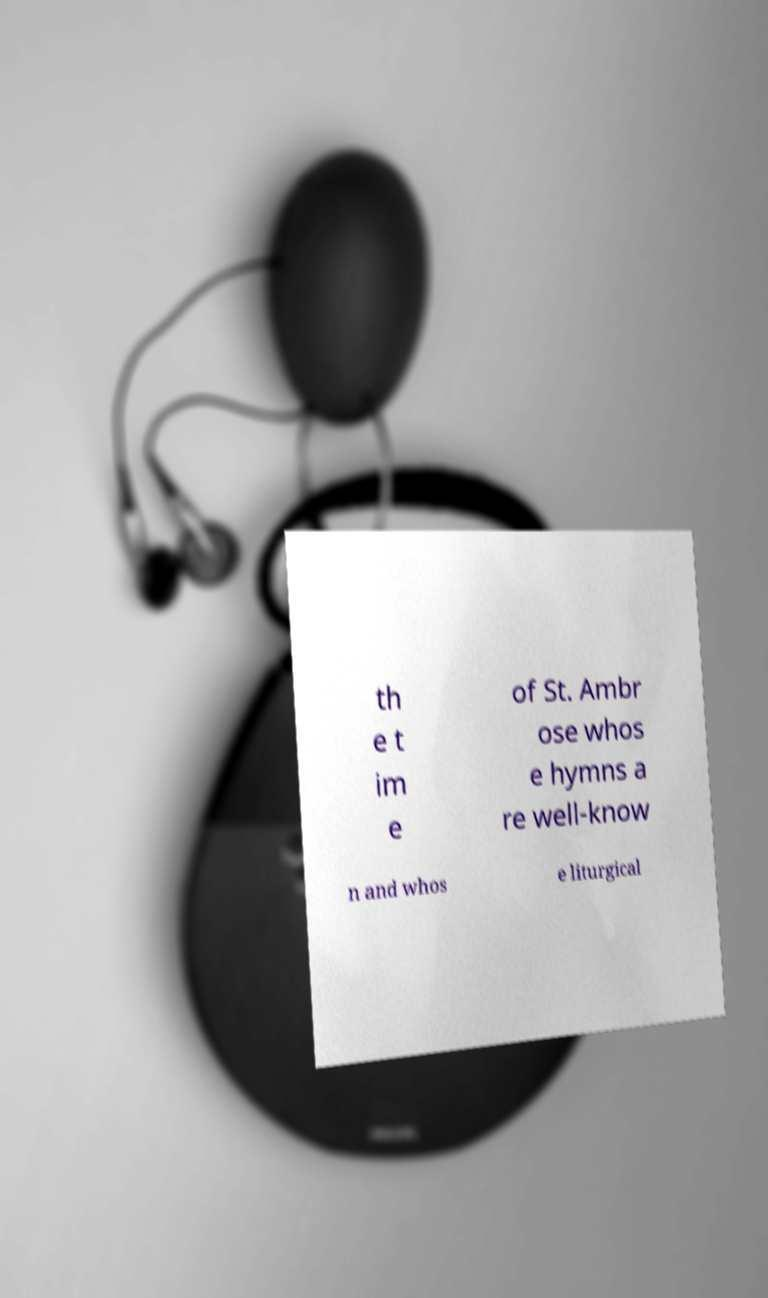For documentation purposes, I need the text within this image transcribed. Could you provide that? th e t im e of St. Ambr ose whos e hymns a re well-know n and whos e liturgical 